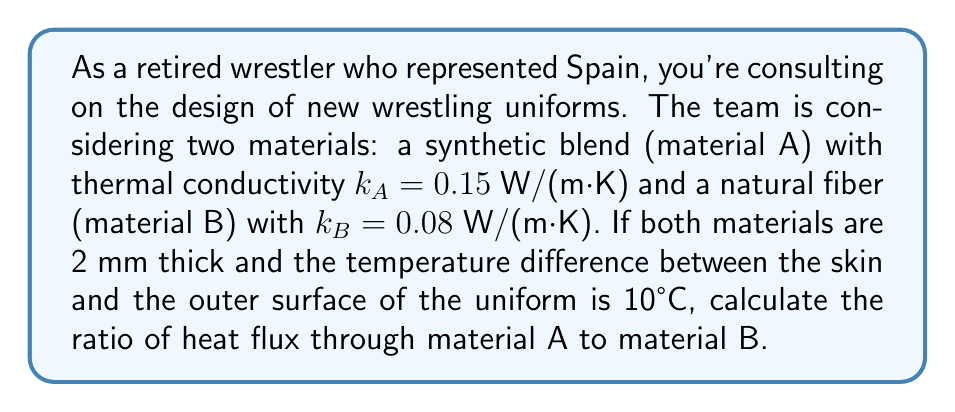Could you help me with this problem? Let's approach this step-by-step using Fourier's law of heat conduction:

1) Fourier's law states that the heat flux $q$ is given by:

   $$q = -k \frac{dT}{dx}$$

   where $k$ is the thermal conductivity, and $\frac{dT}{dx}$ is the temperature gradient.

2) For a uniform material of thickness $L$ with temperature difference $\Delta T$, this simplifies to:

   $$q = k \frac{\Delta T}{L}$$

3) For material A:
   $$q_A = k_A \frac{\Delta T}{L_A} = 0.15 \frac{10}{0.002} = 750 \text{ W/m}^2$$

4) For material B:
   $$q_B = k_B \frac{\Delta T}{L_B} = 0.08 \frac{10}{0.002} = 400 \text{ W/m}^2$$

5) The ratio of heat flux through A to B is:

   $$\frac{q_A}{q_B} = \frac{750}{400} = 1.875$$

This means the heat flux through material A is 1.875 times greater than through material B.
Answer: 1.875 